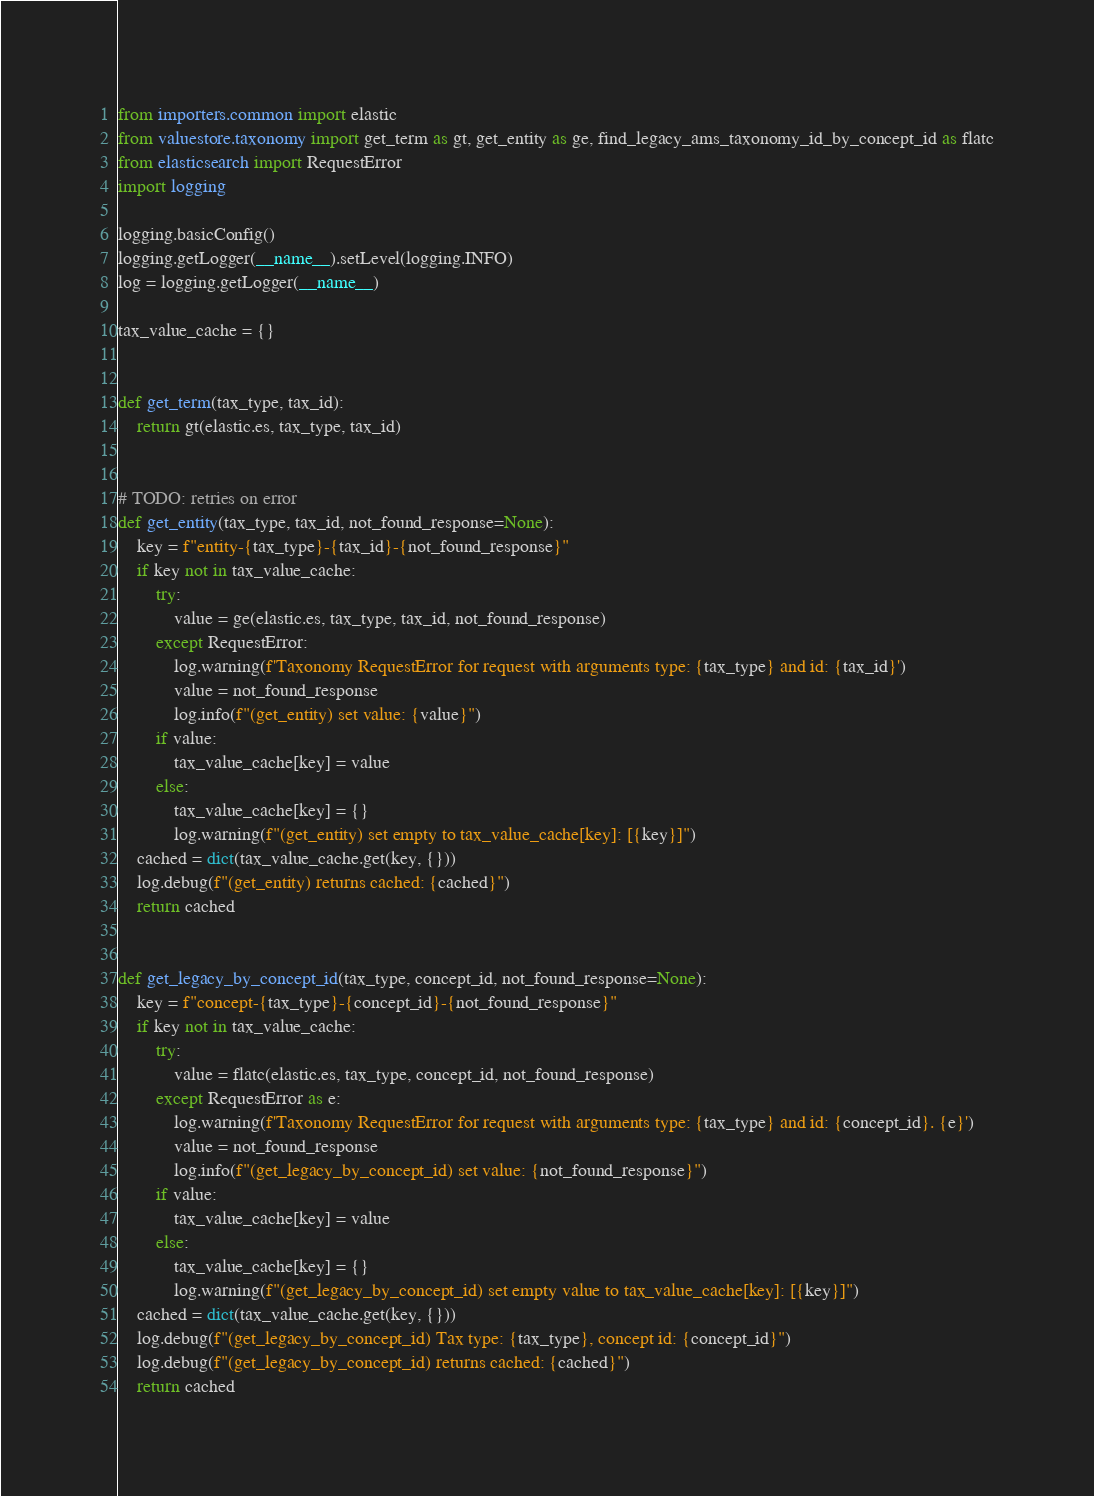Convert code to text. <code><loc_0><loc_0><loc_500><loc_500><_Python_>from importers.common import elastic
from valuestore.taxonomy import get_term as gt, get_entity as ge, find_legacy_ams_taxonomy_id_by_concept_id as flatc
from elasticsearch import RequestError
import logging

logging.basicConfig()
logging.getLogger(__name__).setLevel(logging.INFO)
log = logging.getLogger(__name__)

tax_value_cache = {}


def get_term(tax_type, tax_id):
    return gt(elastic.es, tax_type, tax_id)


# TODO: retries on error
def get_entity(tax_type, tax_id, not_found_response=None):
    key = f"entity-{tax_type}-{tax_id}-{not_found_response}"
    if key not in tax_value_cache:
        try:
            value = ge(elastic.es, tax_type, tax_id, not_found_response)
        except RequestError:
            log.warning(f'Taxonomy RequestError for request with arguments type: {tax_type} and id: {tax_id}')
            value = not_found_response
            log.info(f"(get_entity) set value: {value}")
        if value:
            tax_value_cache[key] = value
        else:
            tax_value_cache[key] = {}
            log.warning(f"(get_entity) set empty to tax_value_cache[key]: [{key}]")
    cached = dict(tax_value_cache.get(key, {}))
    log.debug(f"(get_entity) returns cached: {cached}")
    return cached


def get_legacy_by_concept_id(tax_type, concept_id, not_found_response=None):
    key = f"concept-{tax_type}-{concept_id}-{not_found_response}"
    if key not in tax_value_cache:
        try:
            value = flatc(elastic.es, tax_type, concept_id, not_found_response)
        except RequestError as e:
            log.warning(f'Taxonomy RequestError for request with arguments type: {tax_type} and id: {concept_id}. {e}')
            value = not_found_response
            log.info(f"(get_legacy_by_concept_id) set value: {not_found_response}")
        if value:
            tax_value_cache[key] = value
        else:
            tax_value_cache[key] = {}
            log.warning(f"(get_legacy_by_concept_id) set empty value to tax_value_cache[key]: [{key}]")
    cached = dict(tax_value_cache.get(key, {}))
    log.debug(f"(get_legacy_by_concept_id) Tax type: {tax_type}, concept id: {concept_id}")
    log.debug(f"(get_legacy_by_concept_id) returns cached: {cached}")
    return cached
</code> 